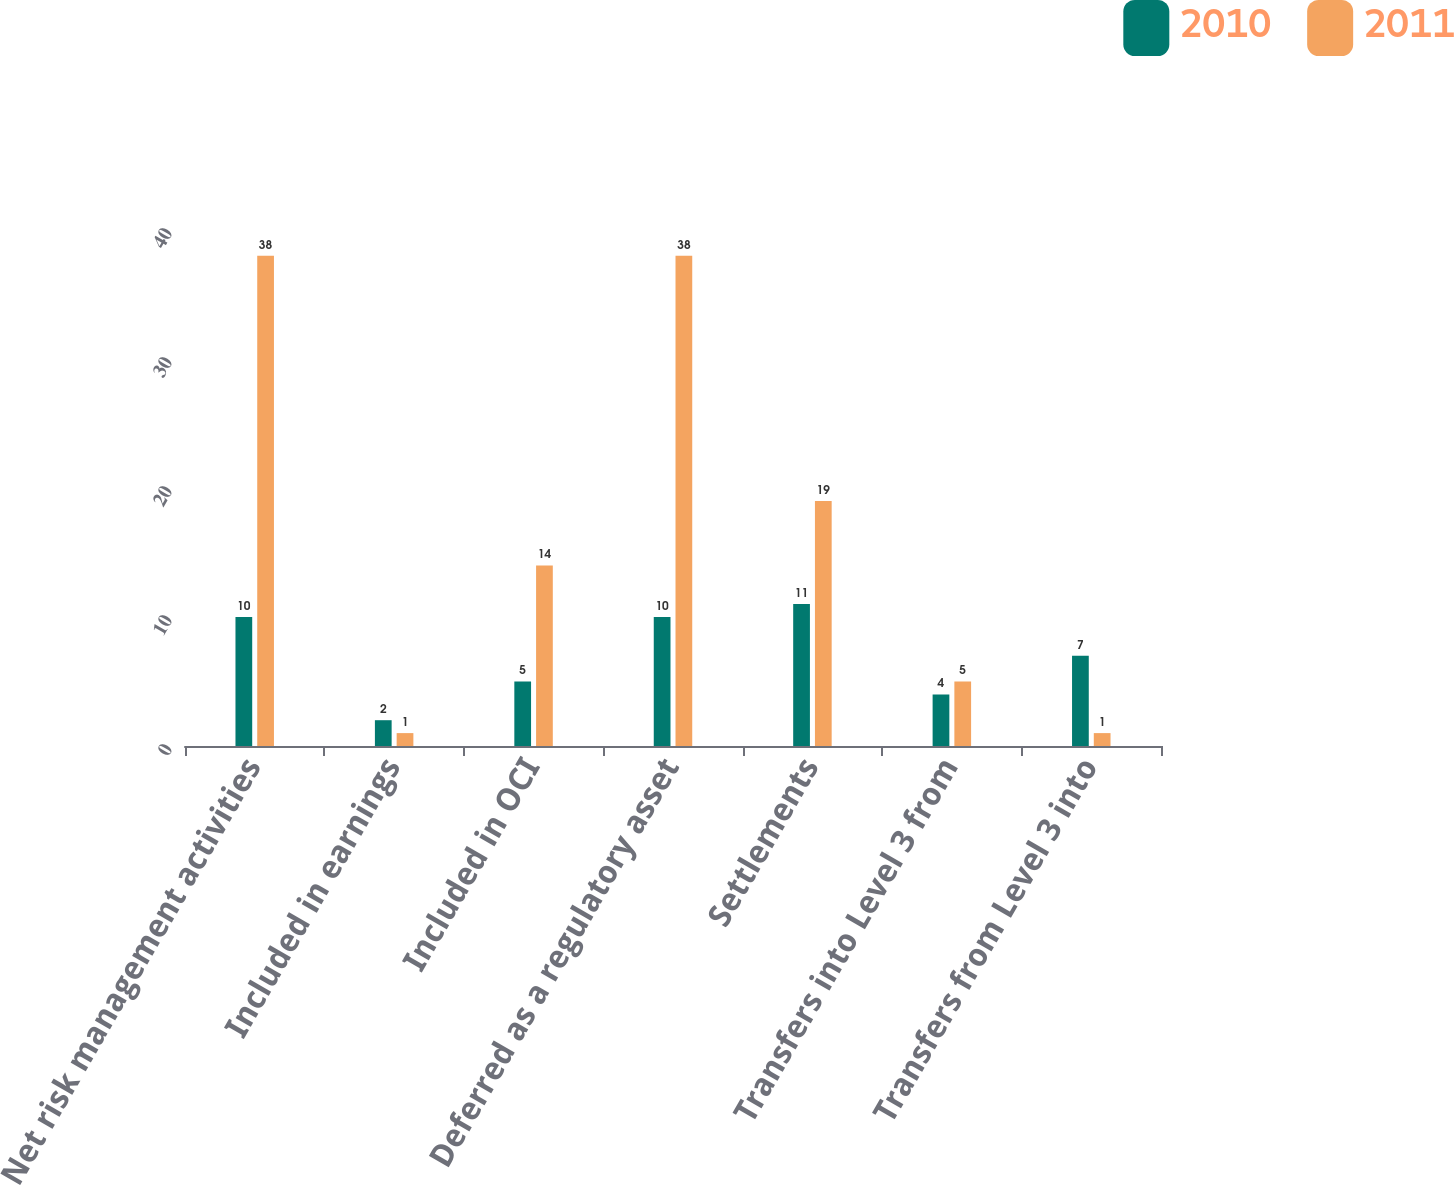<chart> <loc_0><loc_0><loc_500><loc_500><stacked_bar_chart><ecel><fcel>Net risk management activities<fcel>Included in earnings<fcel>Included in OCI<fcel>Deferred as a regulatory asset<fcel>Settlements<fcel>Transfers into Level 3 from<fcel>Transfers from Level 3 into<nl><fcel>2010<fcel>10<fcel>2<fcel>5<fcel>10<fcel>11<fcel>4<fcel>7<nl><fcel>2011<fcel>38<fcel>1<fcel>14<fcel>38<fcel>19<fcel>5<fcel>1<nl></chart> 